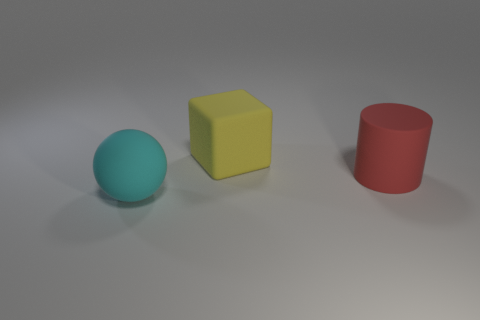What number of things are the same size as the rubber ball?
Your response must be concise. 2. What number of things are big yellow blocks or objects that are behind the big rubber sphere?
Provide a short and direct response. 2. There is a big rubber thing that is behind the large cyan thing and to the left of the red rubber thing; what is its color?
Give a very brief answer. Yellow. Is the cyan thing the same size as the red matte cylinder?
Make the answer very short. Yes. There is a large matte object that is in front of the red rubber object; what is its color?
Provide a succinct answer. Cyan. What is the color of the ball that is the same size as the rubber cylinder?
Offer a very short reply. Cyan. There is a thing to the right of the big yellow rubber cube; what is its material?
Provide a short and direct response. Rubber. The large matte cylinder has what color?
Your answer should be compact. Red. Is the number of matte cubes to the left of the big red object greater than the number of big matte spheres that are on the right side of the sphere?
Your response must be concise. Yes. What number of other things are there of the same shape as the yellow rubber object?
Ensure brevity in your answer.  0. 